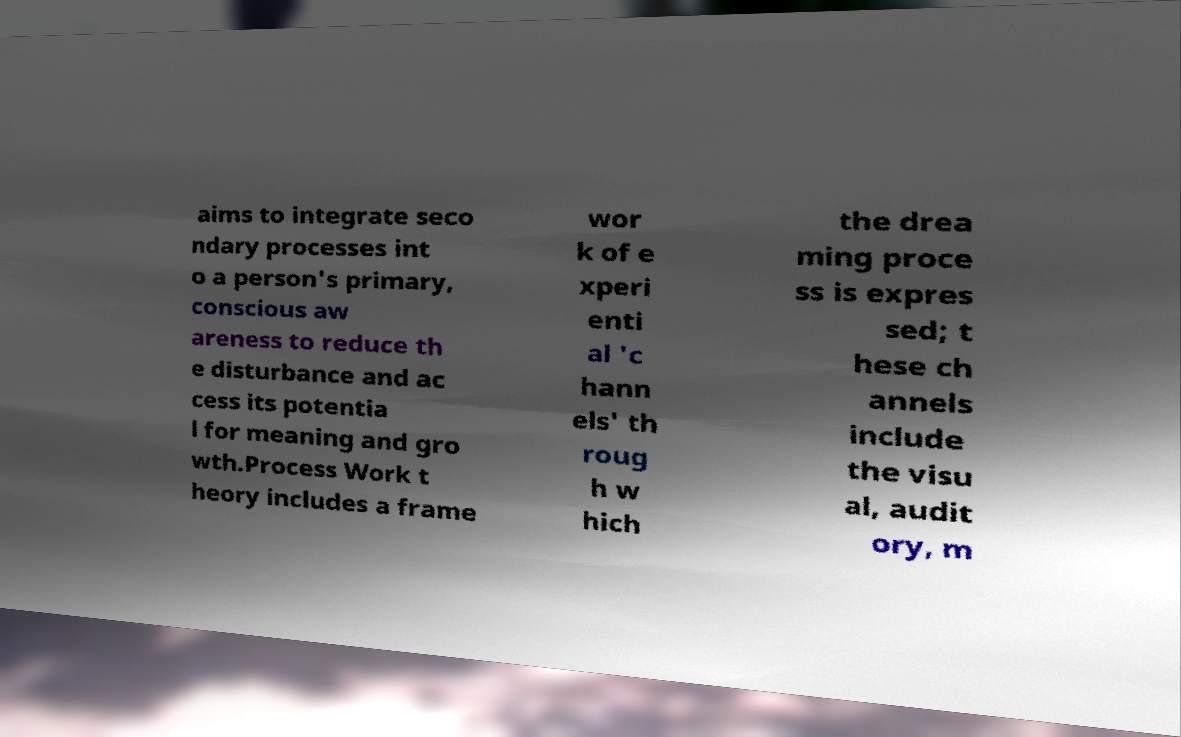Could you assist in decoding the text presented in this image and type it out clearly? aims to integrate seco ndary processes int o a person's primary, conscious aw areness to reduce th e disturbance and ac cess its potentia l for meaning and gro wth.Process Work t heory includes a frame wor k of e xperi enti al 'c hann els' th roug h w hich the drea ming proce ss is expres sed; t hese ch annels include the visu al, audit ory, m 